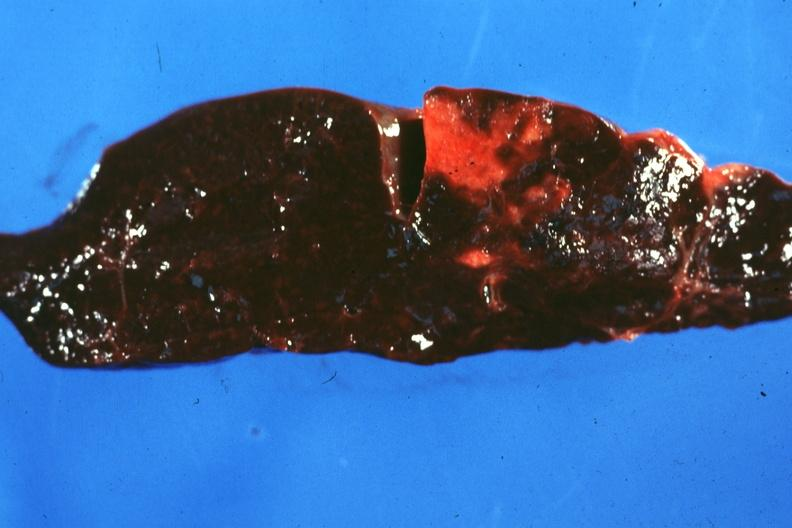s endometritis postpartum present?
Answer the question using a single word or phrase. No 